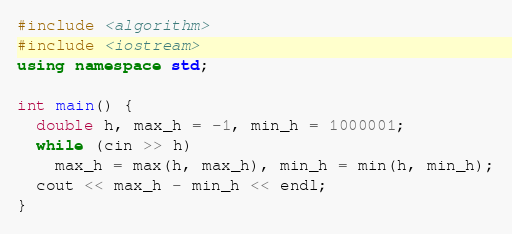Convert code to text. <code><loc_0><loc_0><loc_500><loc_500><_C++_>#include <algorithm>
#include <iostream>
using namespace std;

int main() {
  double h, max_h = -1, min_h = 1000001;
  while (cin >> h)
    max_h = max(h, max_h), min_h = min(h, min_h);
  cout << max_h - min_h << endl;
}
</code> 